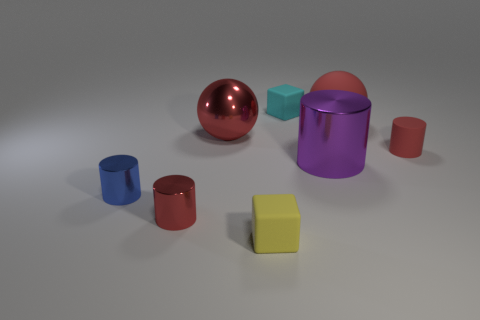Subtract 1 cylinders. How many cylinders are left? 3 Add 1 blue things. How many objects exist? 9 Add 3 shiny cylinders. How many shiny cylinders are left? 6 Add 4 rubber cylinders. How many rubber cylinders exist? 5 Subtract 1 cyan blocks. How many objects are left? 7 Subtract all large purple cylinders. Subtract all big gray rubber balls. How many objects are left? 7 